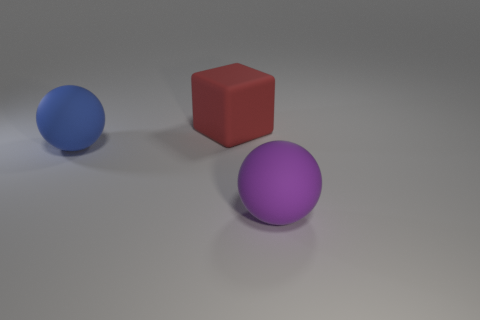Add 2 blue objects. How many objects exist? 5 Add 2 big things. How many big things exist? 5 Subtract 1 red cubes. How many objects are left? 2 Subtract all spheres. How many objects are left? 1 Subtract all purple rubber things. Subtract all red rubber blocks. How many objects are left? 1 Add 1 red blocks. How many red blocks are left? 2 